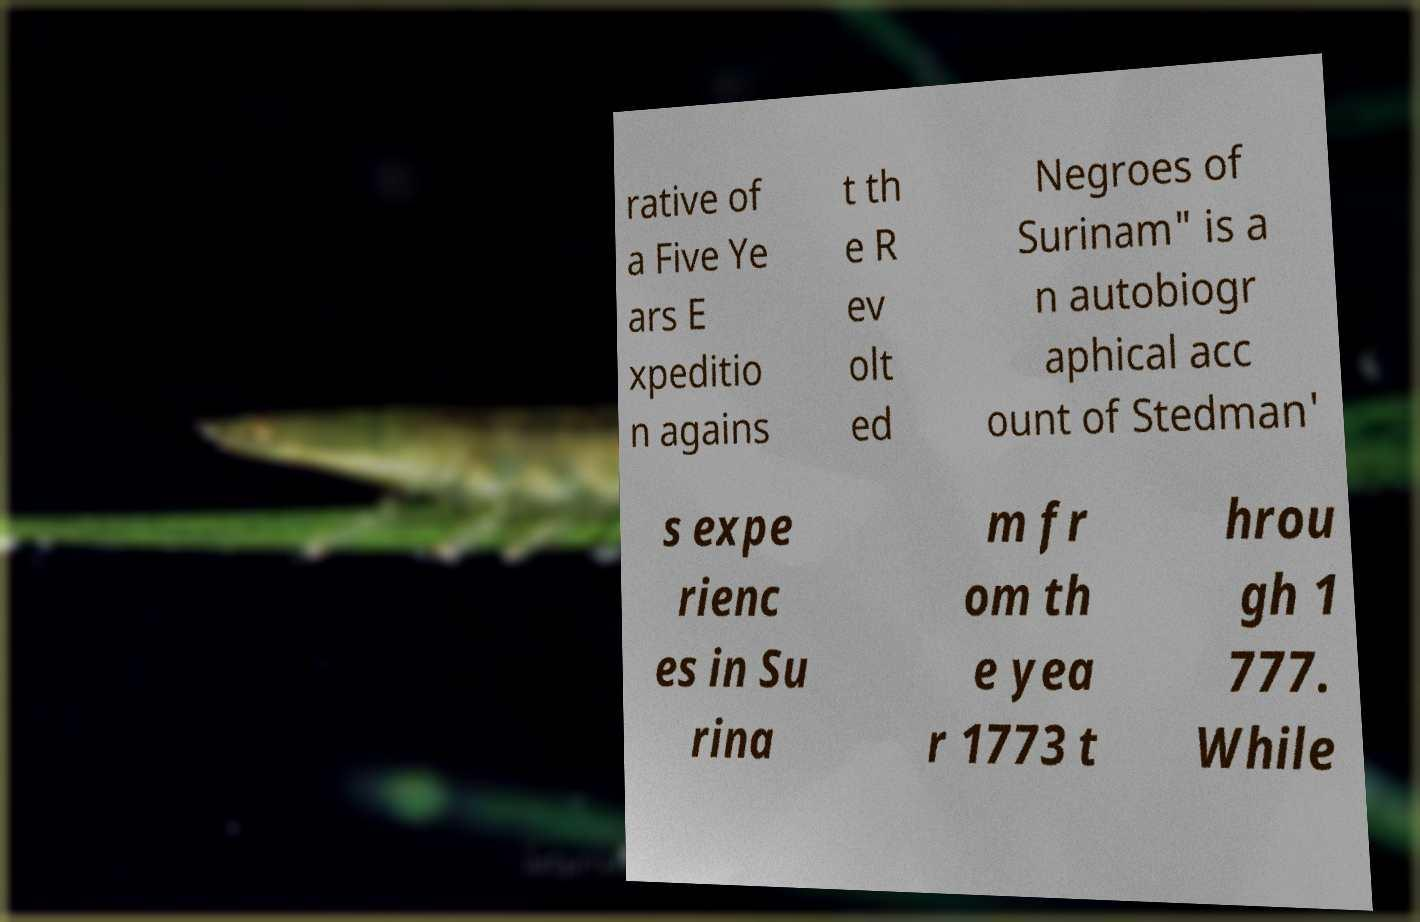I need the written content from this picture converted into text. Can you do that? rative of a Five Ye ars E xpeditio n agains t th e R ev olt ed Negroes of Surinam" is a n autobiogr aphical acc ount of Stedman' s expe rienc es in Su rina m fr om th e yea r 1773 t hrou gh 1 777. While 